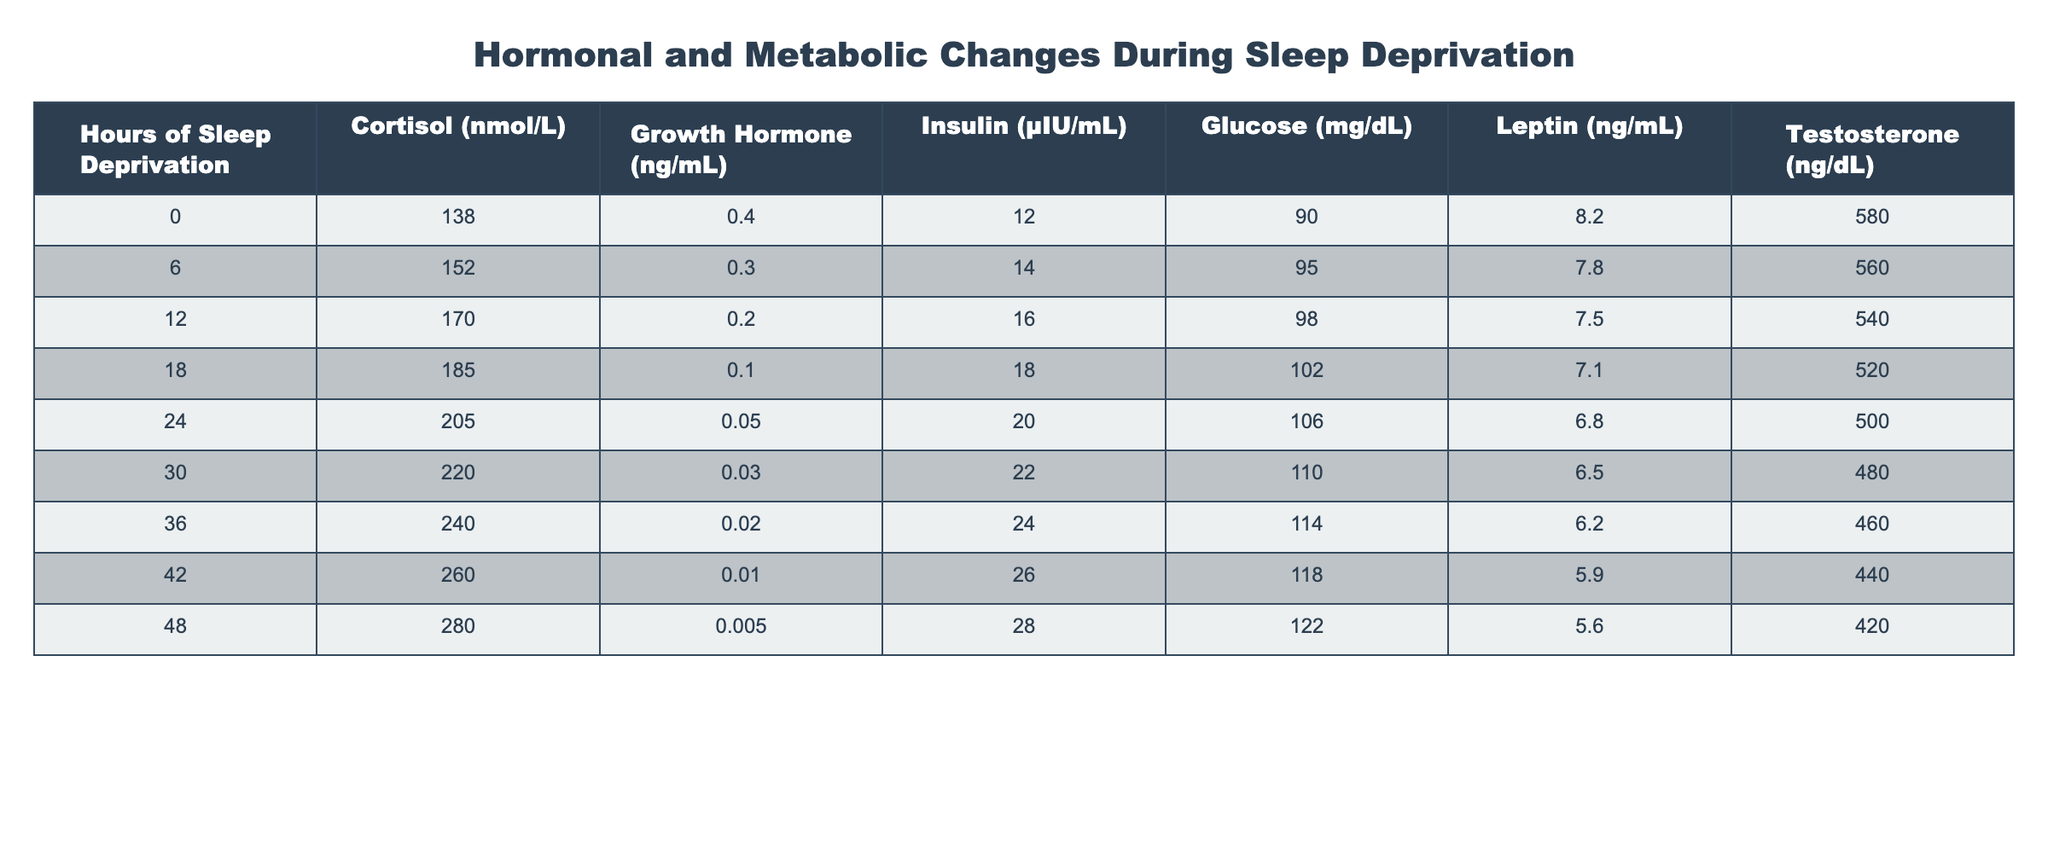What is the cortisol level after 24 hours of sleep deprivation? The table lists the cortisol level corresponding to 24 hours of sleep deprivation. It shows that the cortisol level at this point is 205 nmol/L.
Answer: 205 nmol/L What happens to insulin levels from 0 to 48 hours of sleep deprivation? Looking at the insulin levels in the table, it starts at 12 μIU/mL at 0 hours, increasing to 26 μIU/mL at 48 hours, indicating a consistent rise in insulin levels with sleep deprivation.
Answer: Insulin levels increase What is the difference in testosterone levels between 0 and 48 hours of sleep deprivation? The testosterone level starts at 580 ng/dL at 0 hours and decreases to 420 ng/dL at 48 hours. The difference is calculated as 580 - 420 = 160 ng/dL.
Answer: 160 ng/dL What is the average glucose level during the sleep deprivation periods represented in the table? The glucose levels are 90, 95, 98, 102, 106, 110, 114, 118, and 122 mg/dL. Adding these values gives a total of 1,095, and dividing by 9 (the number of data points) yields an average of 121.67 mg/dL.
Answer: 121.67 mg/dL After how many hours does cortisol level exceed 240 nmol/L? By examining the cortisol levels, they start at 138 nmol/L and exceed 240 nmol/L after 36 hours of sleep deprivation, where the cortisol level reaches 240 nmol/L.
Answer: 36 hours Is there a downward trend in growth hormone levels as sleep deprivation increases? The growth hormone levels are checked across the time periods: 0.4, 0.3, 0.2, 0.1, 0.05, 0.03, 0.02, 0.01, 0.005 ng/mL. It is evident that the levels are consistently lowering with increasing sleep deprivation, confirming a downward trend.
Answer: Yes, there is a downward trend How does leptin concentration change from 0 to 48 hours of sleep deprivation? Leptin levels start at 8.2 ng/mL at 0 hours and decrease to 5.6 ng/mL at 48 hours, showing a decline in concentration as sleep deprivation time increases.
Answer: Leptin concentration decreases Which metabolic marker showed the highest value at 0 hours of sleep deprivation? The values at 0 hours are compared: cortisol is 138 nmol/L, growth hormone is 0.4 ng/mL, insulin is 12 μIU/mL, glucose is 90 mg/dL, leptin is 8.2 ng/mL, and testosterone is 580 ng/dL. Among these, testosterone at 580 ng/dL is the highest.
Answer: Testosterone showed the highest value (580 ng/dL) What are the hormonal changes after a period of 18 hours of sleep deprivation? After 18 hours, cortisol is at 185 nmol/L, growth hormone is 0.1 ng/mL, insulin is 18 μIU/mL, glucose is 102 mg/dL, leptin is 7.1 ng/mL, and testosterone is 520 ng/dL. These values indicate particular hormonal responses to this level of deprivation.
Answer: Hormonal values for 18 hours: cortisol 185 nmol/L, growth hormone 0.1 ng/mL, insulin 18 μIU/mL, glucose 102 mg/dL, leptin 7.1 ng/mL, testosterone 520 ng/dL 